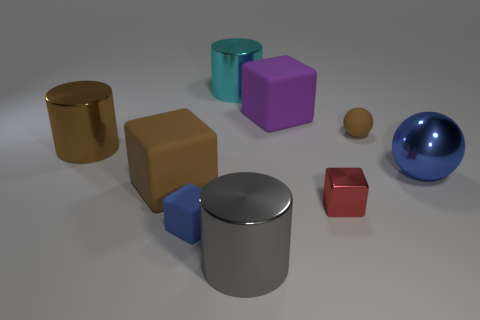Subtract all big brown cylinders. How many cylinders are left? 2 Subtract 2 spheres. How many spheres are left? 0 Add 1 big gray things. How many objects exist? 10 Subtract all cubes. How many objects are left? 5 Add 9 big purple rubber things. How many big purple rubber things exist? 10 Subtract all gray cylinders. How many cylinders are left? 2 Subtract 0 green balls. How many objects are left? 9 Subtract all yellow cylinders. Subtract all yellow spheres. How many cylinders are left? 3 Subtract all green balls. How many blue cylinders are left? 0 Subtract all large gray things. Subtract all tiny matte blocks. How many objects are left? 7 